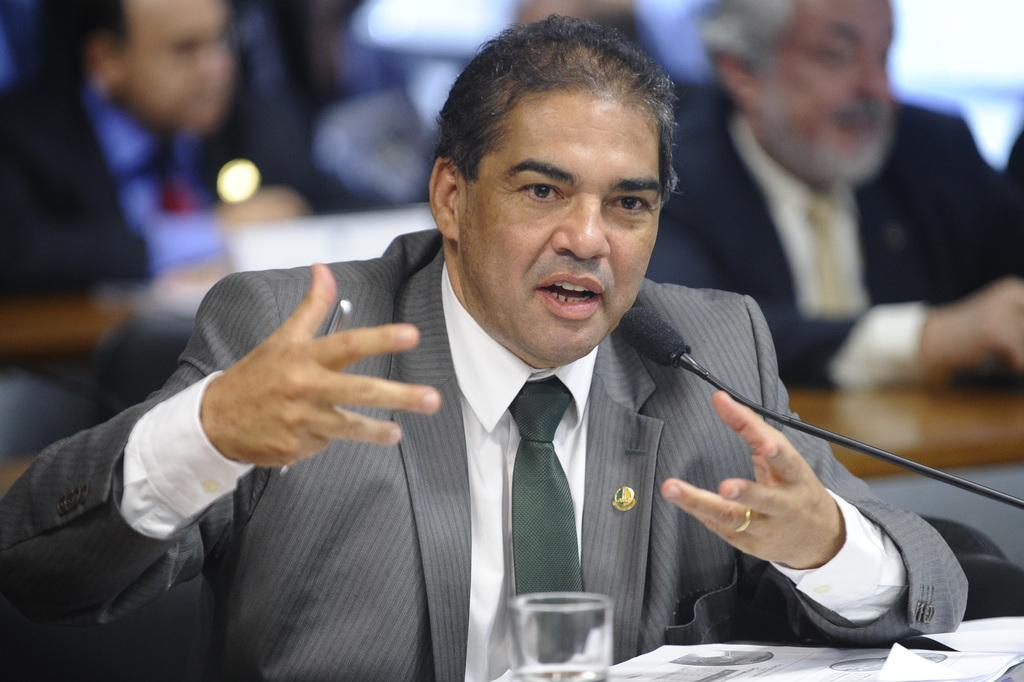Could you give a brief overview of what you see in this image? In this image I can see a person wearing white shirt and black blazer is sitting in front of the desk and on the desk I can see few papers, a glass and a microphone. I can see the blurry background in which I can see few other persons sitting. 